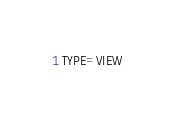<code> <loc_0><loc_0><loc_500><loc_500><_VisualBasic_>TYPE=VIEW</code> 